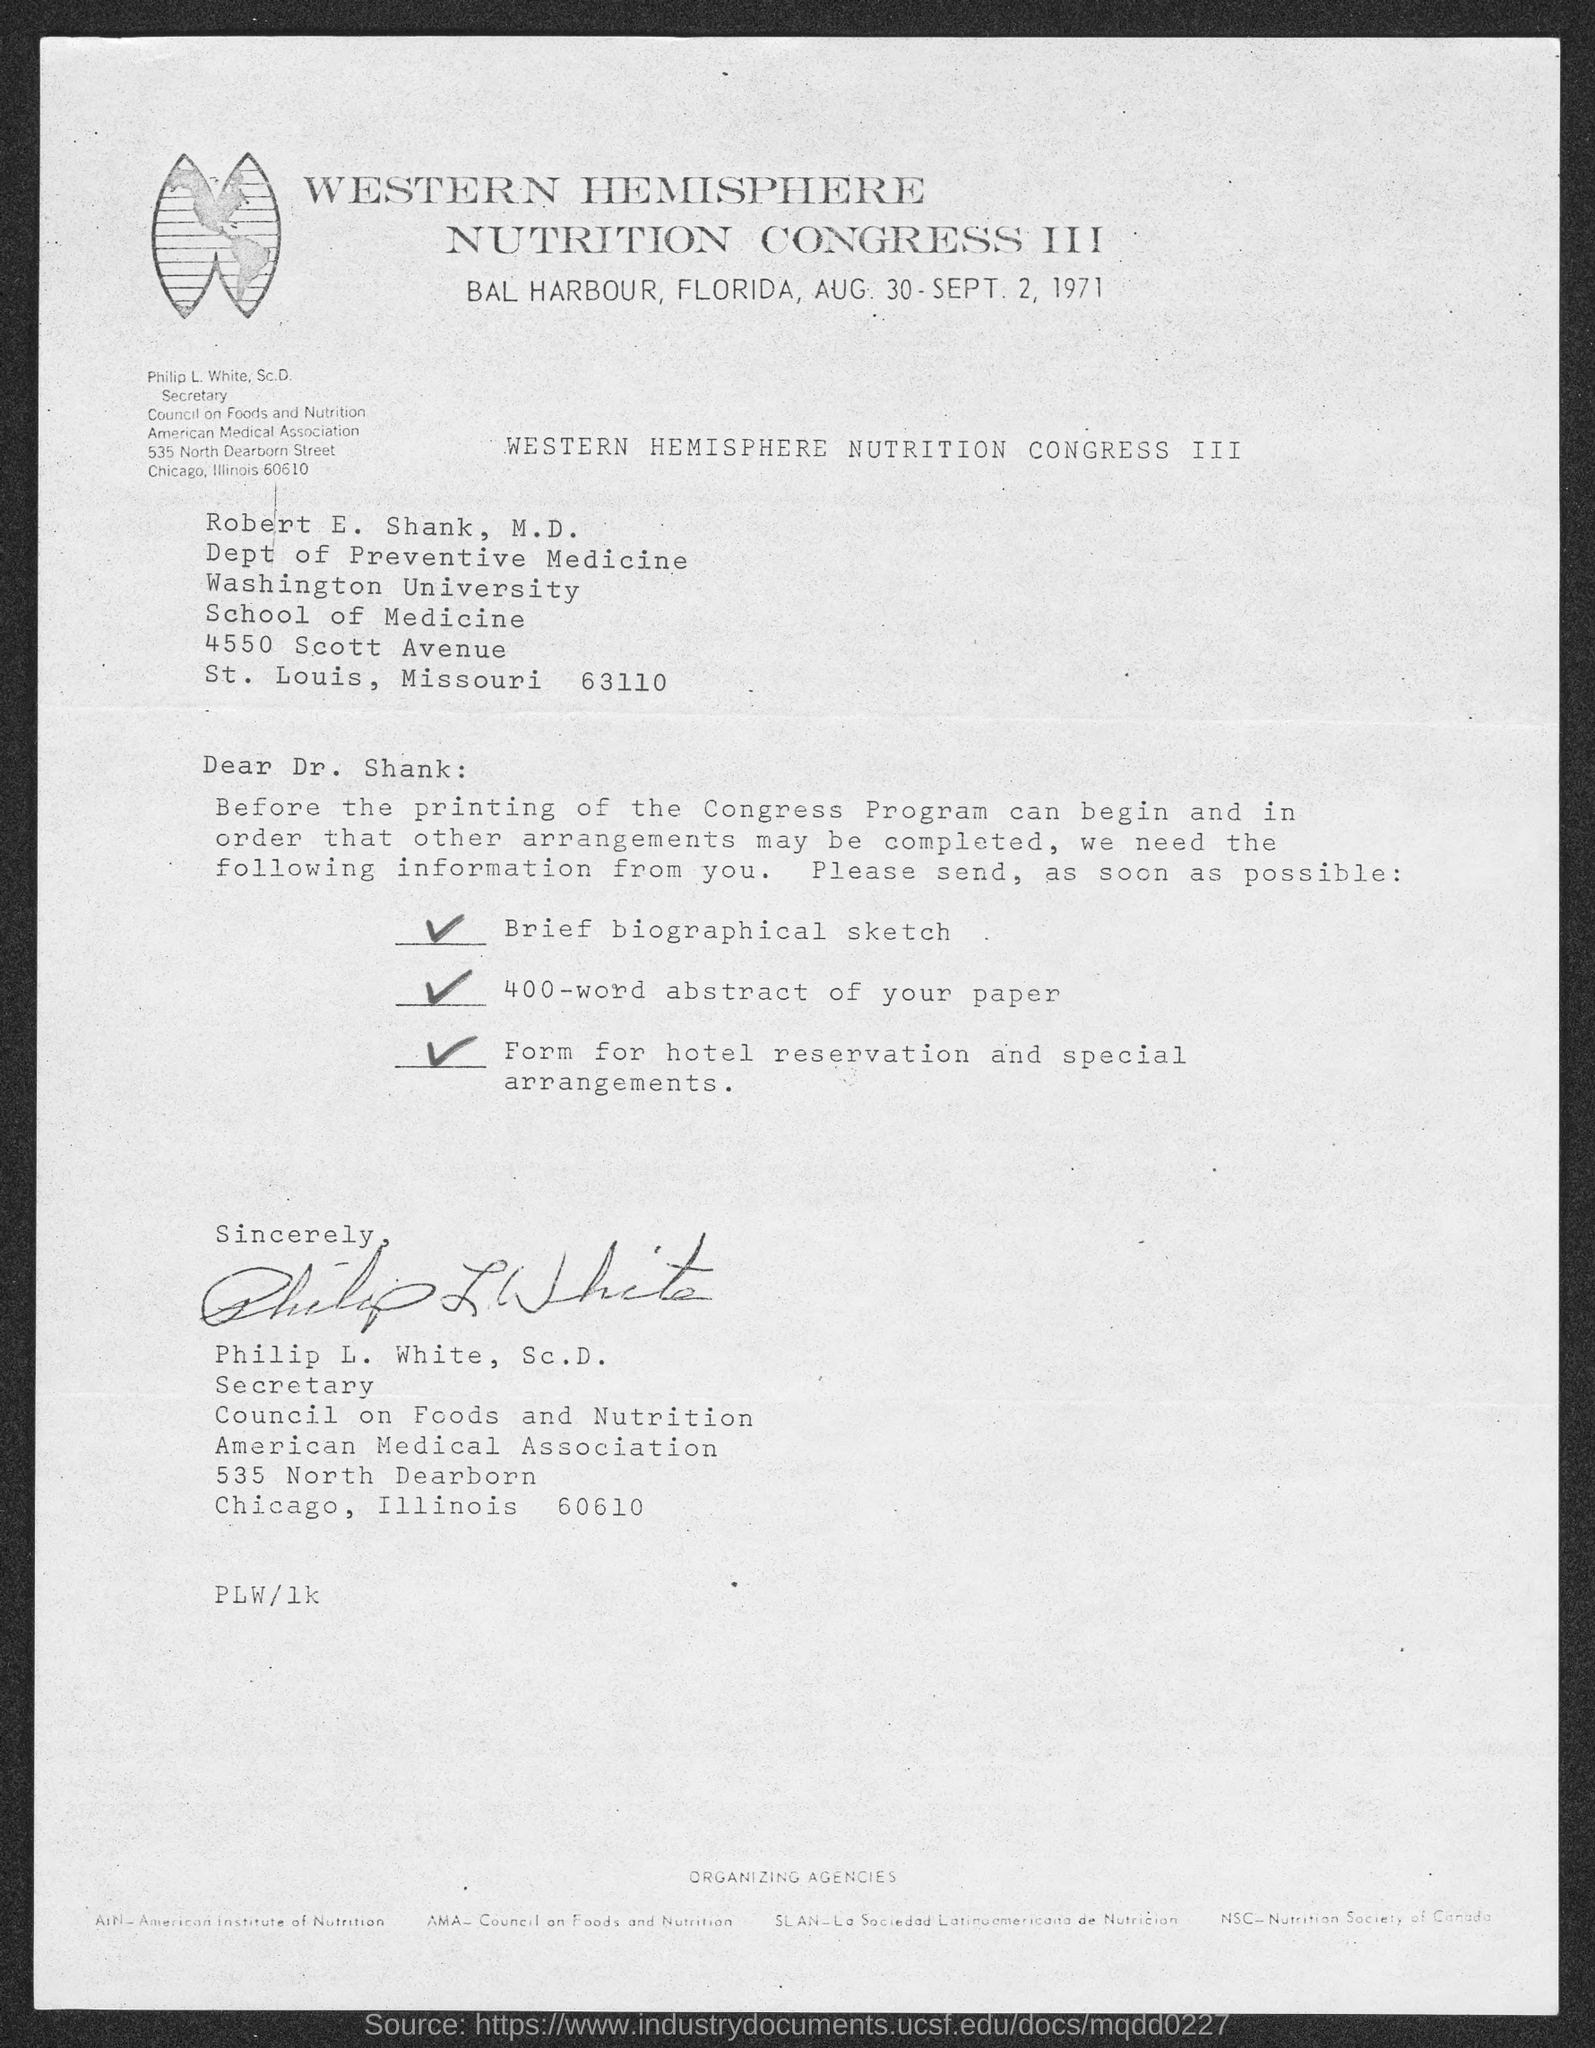Where did western hemisphere nutrition congress iii take place?
Offer a terse response. Bal Harbour, Florida. In which year western hemisphere nutrition congress iii take place?
Provide a succinct answer. 1971. To whom this letter is written to?
Provide a succinct answer. Robert E. Shank, M.D. 